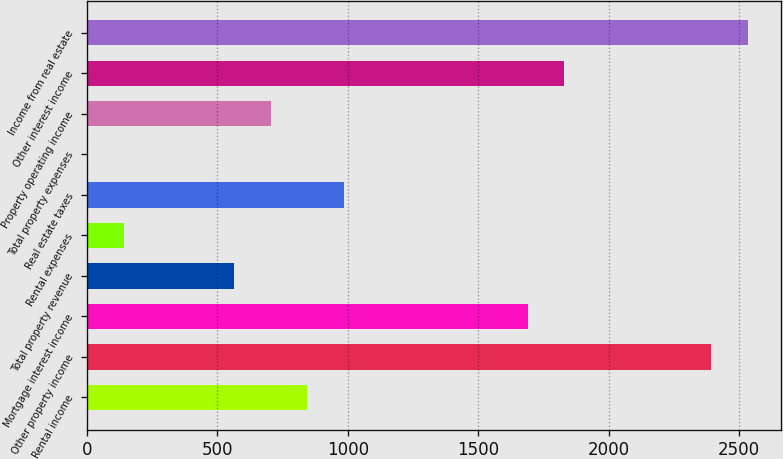Convert chart. <chart><loc_0><loc_0><loc_500><loc_500><bar_chart><fcel>Rental income<fcel>Other property income<fcel>Mortgage interest income<fcel>Total property revenue<fcel>Rental expenses<fcel>Real estate taxes<fcel>Total property expenses<fcel>Property operating income<fcel>Other interest income<fcel>Income from real estate<nl><fcel>844.74<fcel>2392.33<fcel>1688.88<fcel>563.36<fcel>141.29<fcel>985.43<fcel>0.6<fcel>704.05<fcel>1829.57<fcel>2533.02<nl></chart> 